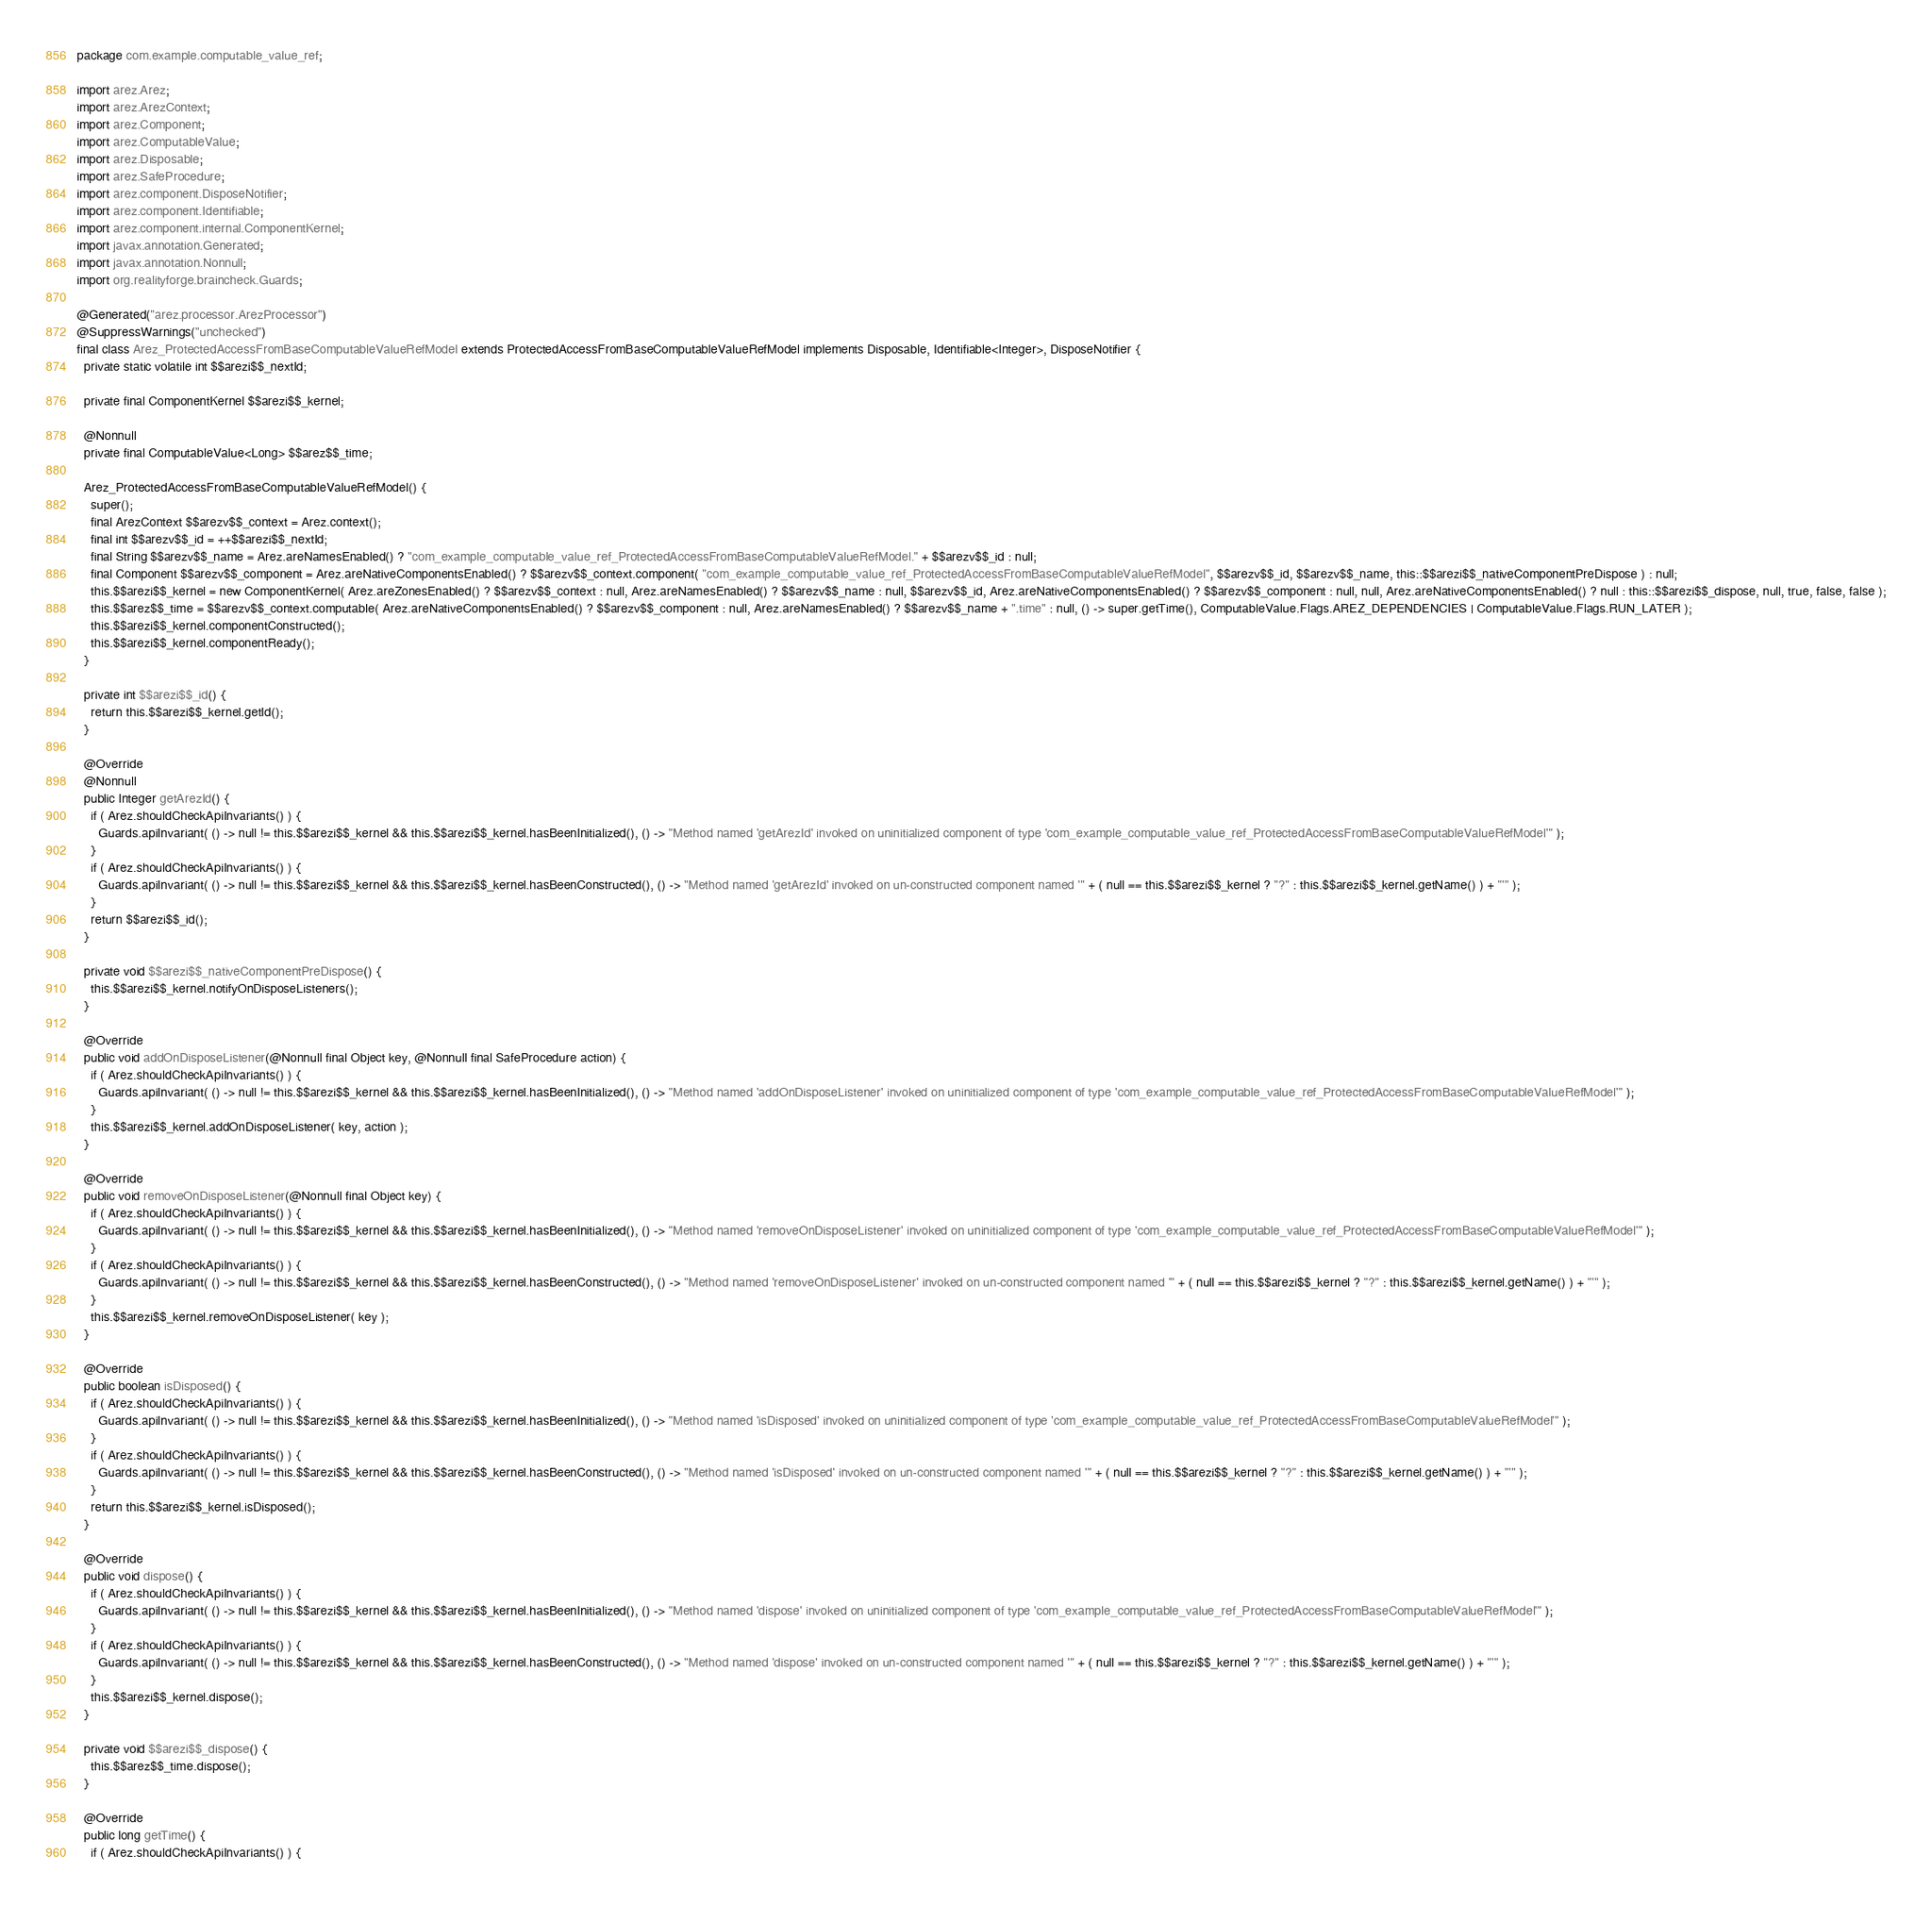<code> <loc_0><loc_0><loc_500><loc_500><_Java_>package com.example.computable_value_ref;

import arez.Arez;
import arez.ArezContext;
import arez.Component;
import arez.ComputableValue;
import arez.Disposable;
import arez.SafeProcedure;
import arez.component.DisposeNotifier;
import arez.component.Identifiable;
import arez.component.internal.ComponentKernel;
import javax.annotation.Generated;
import javax.annotation.Nonnull;
import org.realityforge.braincheck.Guards;

@Generated("arez.processor.ArezProcessor")
@SuppressWarnings("unchecked")
final class Arez_ProtectedAccessFromBaseComputableValueRefModel extends ProtectedAccessFromBaseComputableValueRefModel implements Disposable, Identifiable<Integer>, DisposeNotifier {
  private static volatile int $$arezi$$_nextId;

  private final ComponentKernel $$arezi$$_kernel;

  @Nonnull
  private final ComputableValue<Long> $$arez$$_time;

  Arez_ProtectedAccessFromBaseComputableValueRefModel() {
    super();
    final ArezContext $$arezv$$_context = Arez.context();
    final int $$arezv$$_id = ++$$arezi$$_nextId;
    final String $$arezv$$_name = Arez.areNamesEnabled() ? "com_example_computable_value_ref_ProtectedAccessFromBaseComputableValueRefModel." + $$arezv$$_id : null;
    final Component $$arezv$$_component = Arez.areNativeComponentsEnabled() ? $$arezv$$_context.component( "com_example_computable_value_ref_ProtectedAccessFromBaseComputableValueRefModel", $$arezv$$_id, $$arezv$$_name, this::$$arezi$$_nativeComponentPreDispose ) : null;
    this.$$arezi$$_kernel = new ComponentKernel( Arez.areZonesEnabled() ? $$arezv$$_context : null, Arez.areNamesEnabled() ? $$arezv$$_name : null, $$arezv$$_id, Arez.areNativeComponentsEnabled() ? $$arezv$$_component : null, null, Arez.areNativeComponentsEnabled() ? null : this::$$arezi$$_dispose, null, true, false, false );
    this.$$arez$$_time = $$arezv$$_context.computable( Arez.areNativeComponentsEnabled() ? $$arezv$$_component : null, Arez.areNamesEnabled() ? $$arezv$$_name + ".time" : null, () -> super.getTime(), ComputableValue.Flags.AREZ_DEPENDENCIES | ComputableValue.Flags.RUN_LATER );
    this.$$arezi$$_kernel.componentConstructed();
    this.$$arezi$$_kernel.componentReady();
  }

  private int $$arezi$$_id() {
    return this.$$arezi$$_kernel.getId();
  }

  @Override
  @Nonnull
  public Integer getArezId() {
    if ( Arez.shouldCheckApiInvariants() ) {
      Guards.apiInvariant( () -> null != this.$$arezi$$_kernel && this.$$arezi$$_kernel.hasBeenInitialized(), () -> "Method named 'getArezId' invoked on uninitialized component of type 'com_example_computable_value_ref_ProtectedAccessFromBaseComputableValueRefModel'" );
    }
    if ( Arez.shouldCheckApiInvariants() ) {
      Guards.apiInvariant( () -> null != this.$$arezi$$_kernel && this.$$arezi$$_kernel.hasBeenConstructed(), () -> "Method named 'getArezId' invoked on un-constructed component named '" + ( null == this.$$arezi$$_kernel ? "?" : this.$$arezi$$_kernel.getName() ) + "'" );
    }
    return $$arezi$$_id();
  }

  private void $$arezi$$_nativeComponentPreDispose() {
    this.$$arezi$$_kernel.notifyOnDisposeListeners();
  }

  @Override
  public void addOnDisposeListener(@Nonnull final Object key, @Nonnull final SafeProcedure action) {
    if ( Arez.shouldCheckApiInvariants() ) {
      Guards.apiInvariant( () -> null != this.$$arezi$$_kernel && this.$$arezi$$_kernel.hasBeenInitialized(), () -> "Method named 'addOnDisposeListener' invoked on uninitialized component of type 'com_example_computable_value_ref_ProtectedAccessFromBaseComputableValueRefModel'" );
    }
    this.$$arezi$$_kernel.addOnDisposeListener( key, action );
  }

  @Override
  public void removeOnDisposeListener(@Nonnull final Object key) {
    if ( Arez.shouldCheckApiInvariants() ) {
      Guards.apiInvariant( () -> null != this.$$arezi$$_kernel && this.$$arezi$$_kernel.hasBeenInitialized(), () -> "Method named 'removeOnDisposeListener' invoked on uninitialized component of type 'com_example_computable_value_ref_ProtectedAccessFromBaseComputableValueRefModel'" );
    }
    if ( Arez.shouldCheckApiInvariants() ) {
      Guards.apiInvariant( () -> null != this.$$arezi$$_kernel && this.$$arezi$$_kernel.hasBeenConstructed(), () -> "Method named 'removeOnDisposeListener' invoked on un-constructed component named '" + ( null == this.$$arezi$$_kernel ? "?" : this.$$arezi$$_kernel.getName() ) + "'" );
    }
    this.$$arezi$$_kernel.removeOnDisposeListener( key );
  }

  @Override
  public boolean isDisposed() {
    if ( Arez.shouldCheckApiInvariants() ) {
      Guards.apiInvariant( () -> null != this.$$arezi$$_kernel && this.$$arezi$$_kernel.hasBeenInitialized(), () -> "Method named 'isDisposed' invoked on uninitialized component of type 'com_example_computable_value_ref_ProtectedAccessFromBaseComputableValueRefModel'" );
    }
    if ( Arez.shouldCheckApiInvariants() ) {
      Guards.apiInvariant( () -> null != this.$$arezi$$_kernel && this.$$arezi$$_kernel.hasBeenConstructed(), () -> "Method named 'isDisposed' invoked on un-constructed component named '" + ( null == this.$$arezi$$_kernel ? "?" : this.$$arezi$$_kernel.getName() ) + "'" );
    }
    return this.$$arezi$$_kernel.isDisposed();
  }

  @Override
  public void dispose() {
    if ( Arez.shouldCheckApiInvariants() ) {
      Guards.apiInvariant( () -> null != this.$$arezi$$_kernel && this.$$arezi$$_kernel.hasBeenInitialized(), () -> "Method named 'dispose' invoked on uninitialized component of type 'com_example_computable_value_ref_ProtectedAccessFromBaseComputableValueRefModel'" );
    }
    if ( Arez.shouldCheckApiInvariants() ) {
      Guards.apiInvariant( () -> null != this.$$arezi$$_kernel && this.$$arezi$$_kernel.hasBeenConstructed(), () -> "Method named 'dispose' invoked on un-constructed component named '" + ( null == this.$$arezi$$_kernel ? "?" : this.$$arezi$$_kernel.getName() ) + "'" );
    }
    this.$$arezi$$_kernel.dispose();
  }

  private void $$arezi$$_dispose() {
    this.$$arez$$_time.dispose();
  }

  @Override
  public long getTime() {
    if ( Arez.shouldCheckApiInvariants() ) {</code> 